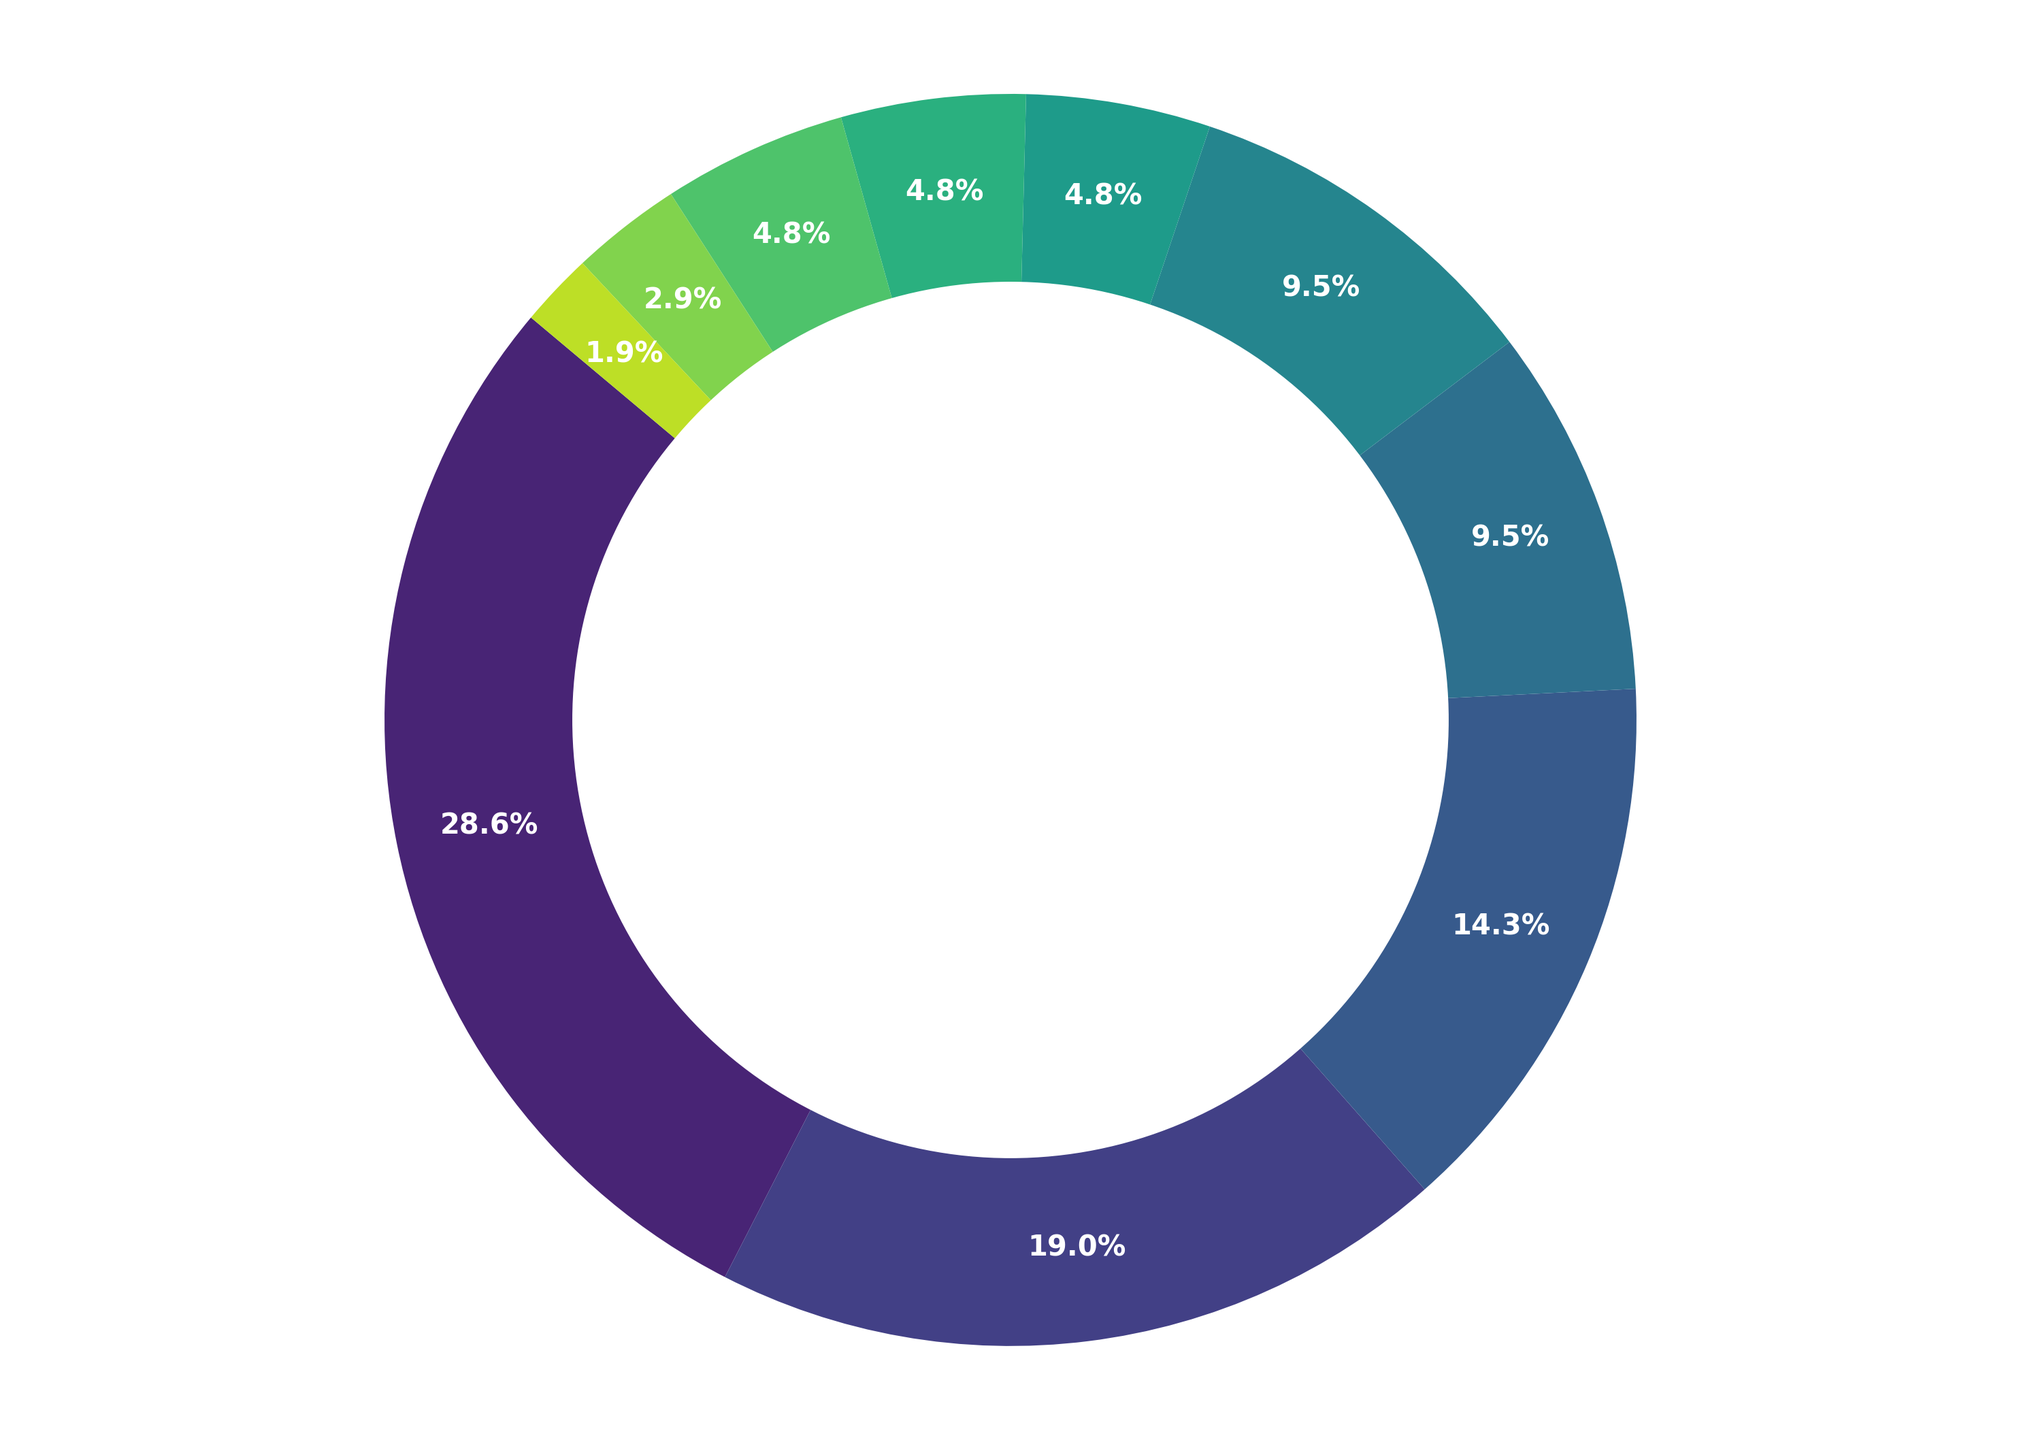what media type has the highest percentage of creative inspiration for video editors? The largest segment on the ring chart is labeled "Films" with a percentage of 30%. This indicates that Films are the top source of creative inspiration.
Answer: Films How much more inspiring is Music compared to Nature? Music has a percentage of 20%, while Nature has a percentage of 5%. The difference between them is 20% - 5% = 15%.
Answer: 15% What is the combined percentage of inspiration from Photography and Video Games? Photography and Video Games both have a percentage of 10% each. Summing them up gives 10% + 10% = 20%.
Answer: 20% Is Art a more significant source of inspiration than Books? Art has a percentage of 15%, whereas Books have a lower percentage of 5%. Thus, Art is a more significant source of inspiration than Books.
Answer: Yes Which media type has the smallest percentage of creative inspiration for video editors? The smallest percentage on the ring chart is for Technology, with a percentage of 2%.
Answer: Technology How does the inspiration from Social Media compare with that from Podcasts? Social Media has a percentage of 5%, while Podcasts have a lower percentage of 3%. So, Social Media is a more significant source of inspiration compared to Podcasts.
Answer: Social Media What is the total percentage of inspiration sources that are below 10%? Sources below 10% include Books (5%), Nature (5%), Social Media (5%), Podcasts (3%), and Technology (2%). Summing up these values, we get 5% + 5% + 5% + 3% + 2% = 20%.
Answer: 20% Which two media types combined make up exactly 40% of the inspiration sources? Films account for 30% and Music for 20%. The combination of these two media types is 30% + 20% = 50%, which is not the answer. Combining Films (30%) and Art (15%) gives 30% + 15% = 45%, which also isn't correct. However, combining Music (20%) and Photography (10%) leads to 20% + 10% = 30%. No two media types accurately combine to make 40%. Therefore, there is no such pair.
Answer: None 